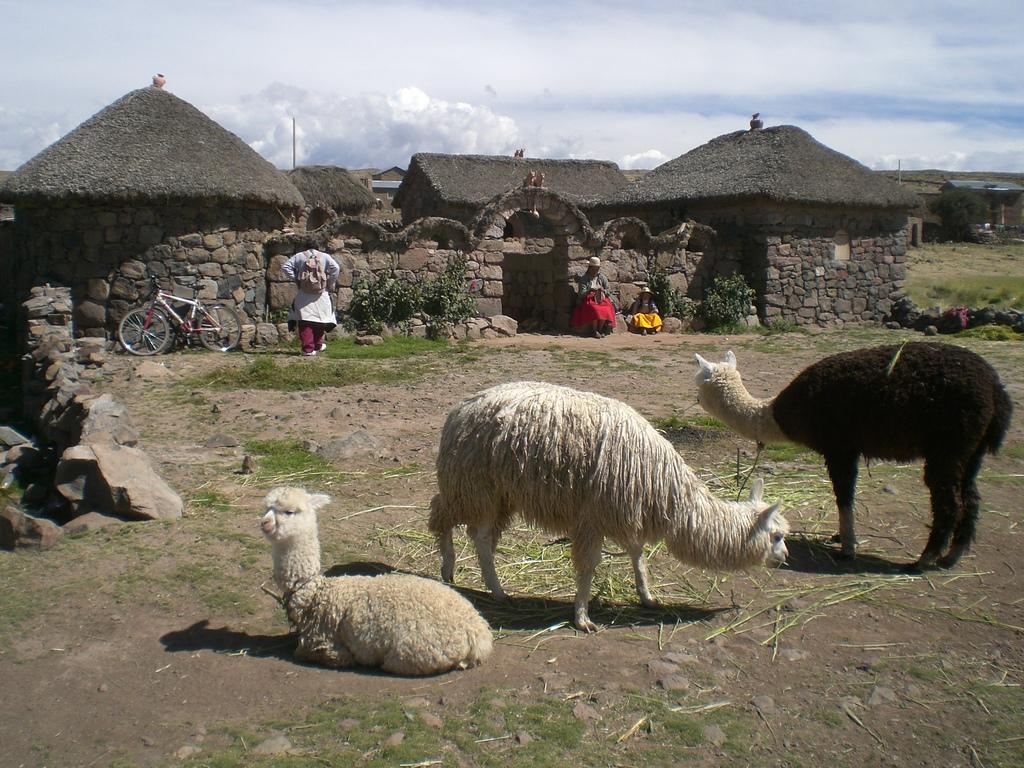How would you summarize this image in a sentence or two? In this image, we can see animals on the ground. Background we can see people, houses, walls, bicycle, plants, few objects, grass and cloudy sky. 